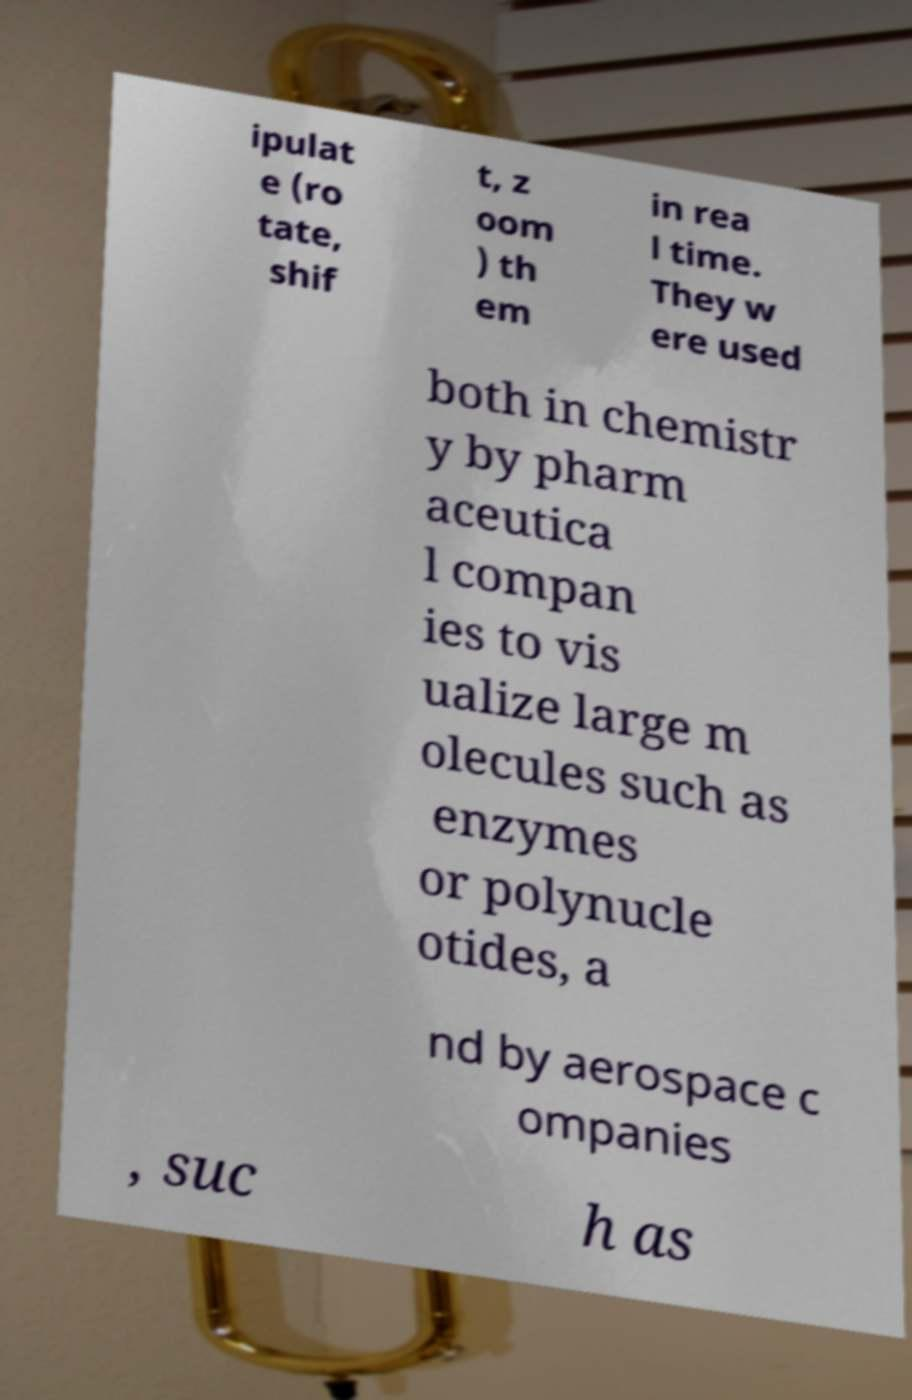I need the written content from this picture converted into text. Can you do that? ipulat e (ro tate, shif t, z oom ) th em in rea l time. They w ere used both in chemistr y by pharm aceutica l compan ies to vis ualize large m olecules such as enzymes or polynucle otides, a nd by aerospace c ompanies , suc h as 